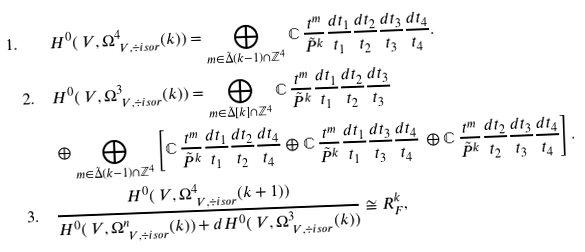Convert formula to latex. <formula><loc_0><loc_0><loc_500><loc_500>1 . \quad & H ^ { 0 } ( \ V , \Omega ^ { 4 } _ { \ V , \div i s o r } ( k ) ) = \bigoplus _ { m \in \tilde { \Delta } ( k - 1 ) \cap \mathbb { Z } ^ { 4 } } \mathbb { C } \, \frac { t ^ { m } } { \tilde { P } ^ { k } } \frac { d t _ { 1 } } { t _ { 1 } } \frac { d t _ { 2 } } { t _ { 2 } } \frac { d t _ { 3 } } { t _ { 3 } } \frac { d t _ { 4 } } { t _ { 4 } } . \\ 2 . \quad & H ^ { 0 } ( \ V , \Omega ^ { 3 } _ { \ V , \div i s o r } ( k ) ) = \bigoplus _ { m \in \tilde { \Delta } [ k ] \cap \mathbb { Z } ^ { 4 } } \mathbb { C } \, \frac { t ^ { m } } { \tilde { P } ^ { k } } \frac { d t _ { 1 } } { t _ { 1 } } \frac { d t _ { 2 } } { t _ { 2 } } \frac { d t _ { 3 } } { t _ { 3 } } \, \\ & \oplus \bigoplus _ { m \in \tilde { \Delta } ( k - 1 ) \cap \mathbb { Z } ^ { 4 } } \left [ \mathbb { C } \, \frac { t ^ { m } } { \tilde { P } ^ { k } } \frac { d t _ { 1 } } { t _ { 1 } } \frac { d t _ { 2 } } { t _ { 2 } } \frac { d t _ { 4 } } { t _ { 4 } } \oplus \mathbb { C } \, \frac { t ^ { m } } { \tilde { P } ^ { k } } \frac { d t _ { 1 } } { t _ { 1 } } \frac { d t _ { 3 } } { t _ { 3 } } \frac { d t _ { 4 } } { t _ { 4 } } \, \oplus \mathbb { C } \, \frac { t ^ { m } } { \tilde { P } ^ { k } } \frac { d t _ { 2 } } { t _ { 2 } } \frac { d t _ { 3 } } { t _ { 3 } } \frac { d t _ { 4 } } { t _ { 4 } } \right ] . \\ 3 . \quad & \frac { H ^ { 0 } ( \ V , \Omega ^ { 4 } _ { \ V , \div i s o r } ( k + 1 ) ) } { H ^ { 0 } ( \ V , \Omega ^ { n } _ { \ V , \div i s o r } ( k ) ) + d H ^ { 0 } ( \ V , \Omega ^ { 3 } _ { \ V , \div i s o r } ( k ) ) } \cong { R } ^ { k } _ { F } ,</formula> 